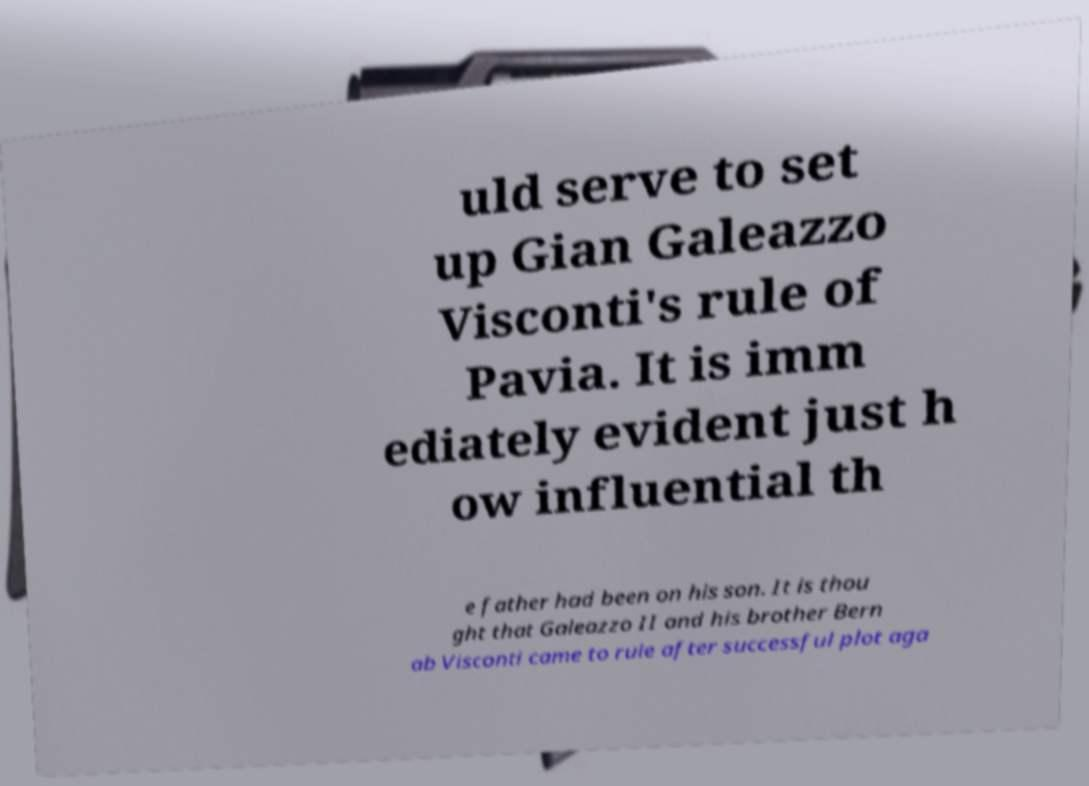Please identify and transcribe the text found in this image. uld serve to set up Gian Galeazzo Visconti's rule of Pavia. It is imm ediately evident just h ow influential th e father had been on his son. It is thou ght that Galeazzo II and his brother Bern ab Visconti came to rule after successful plot aga 